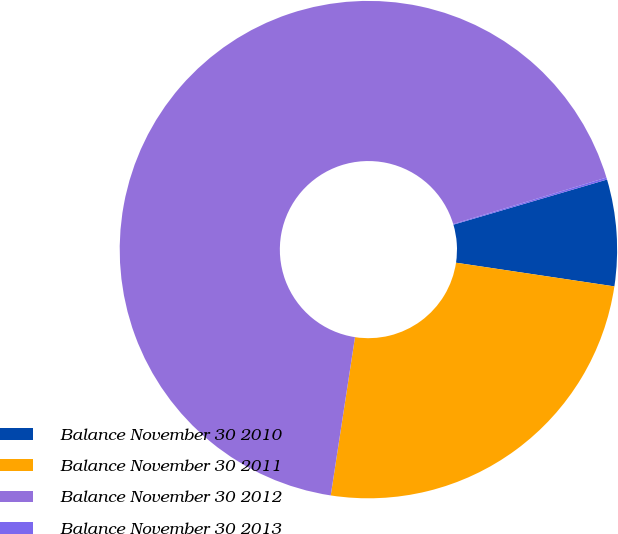Convert chart. <chart><loc_0><loc_0><loc_500><loc_500><pie_chart><fcel>Balance November 30 2010<fcel>Balance November 30 2011<fcel>Balance November 30 2012<fcel>Balance November 30 2013<nl><fcel>6.91%<fcel>25.06%<fcel>67.91%<fcel>0.13%<nl></chart> 